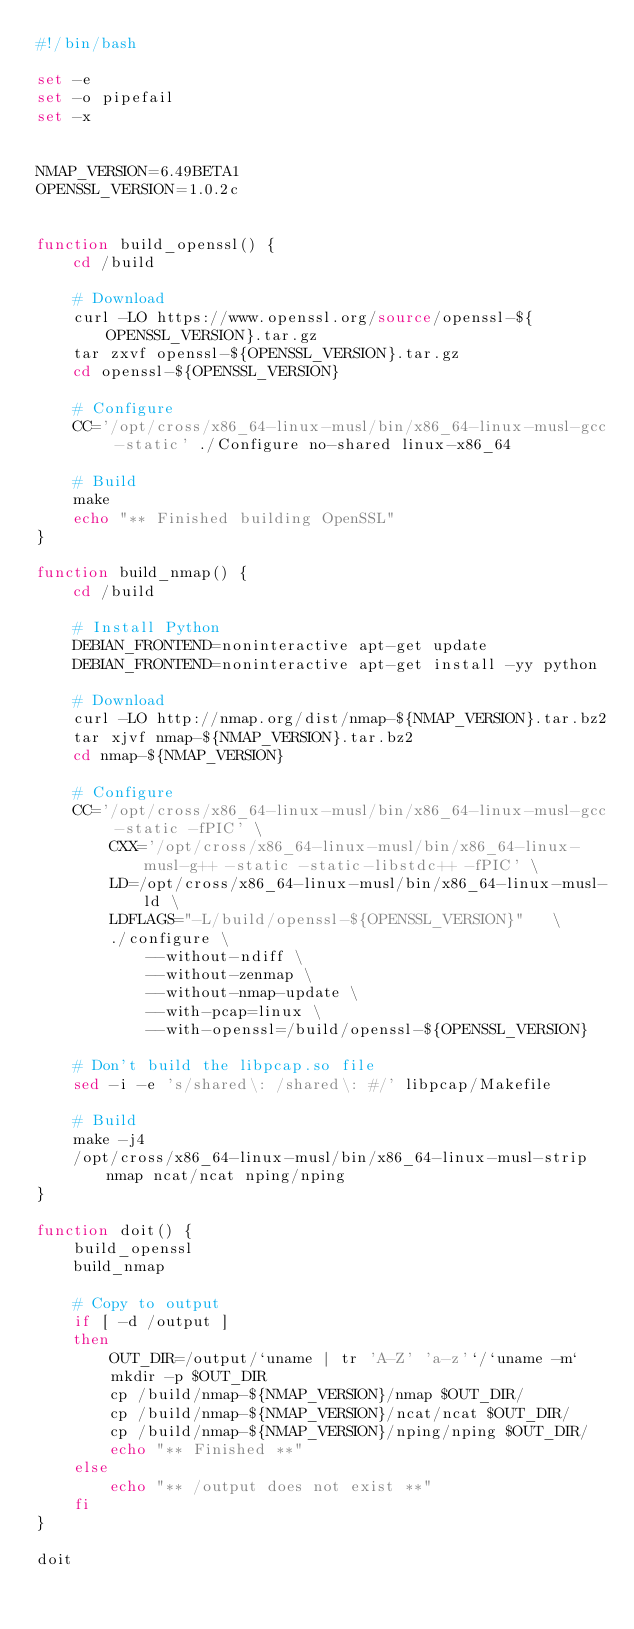<code> <loc_0><loc_0><loc_500><loc_500><_Bash_>#!/bin/bash

set -e
set -o pipefail
set -x


NMAP_VERSION=6.49BETA1
OPENSSL_VERSION=1.0.2c


function build_openssl() {
    cd /build

    # Download
    curl -LO https://www.openssl.org/source/openssl-${OPENSSL_VERSION}.tar.gz
    tar zxvf openssl-${OPENSSL_VERSION}.tar.gz
    cd openssl-${OPENSSL_VERSION}

    # Configure
    CC='/opt/cross/x86_64-linux-musl/bin/x86_64-linux-musl-gcc -static' ./Configure no-shared linux-x86_64

    # Build
    make
    echo "** Finished building OpenSSL"
}

function build_nmap() {
    cd /build

    # Install Python
    DEBIAN_FRONTEND=noninteractive apt-get update
    DEBIAN_FRONTEND=noninteractive apt-get install -yy python

    # Download
    curl -LO http://nmap.org/dist/nmap-${NMAP_VERSION}.tar.bz2
    tar xjvf nmap-${NMAP_VERSION}.tar.bz2
    cd nmap-${NMAP_VERSION}

    # Configure
    CC='/opt/cross/x86_64-linux-musl/bin/x86_64-linux-musl-gcc -static -fPIC' \
        CXX='/opt/cross/x86_64-linux-musl/bin/x86_64-linux-musl-g++ -static -static-libstdc++ -fPIC' \
        LD=/opt/cross/x86_64-linux-musl/bin/x86_64-linux-musl-ld \
        LDFLAGS="-L/build/openssl-${OPENSSL_VERSION}"   \
        ./configure \
            --without-ndiff \
            --without-zenmap \
            --without-nmap-update \
            --with-pcap=linux \
            --with-openssl=/build/openssl-${OPENSSL_VERSION}

    # Don't build the libpcap.so file
    sed -i -e 's/shared\: /shared\: #/' libpcap/Makefile

    # Build
    make -j4
    /opt/cross/x86_64-linux-musl/bin/x86_64-linux-musl-strip nmap ncat/ncat nping/nping
}

function doit() {
    build_openssl
    build_nmap

    # Copy to output
    if [ -d /output ]
    then
        OUT_DIR=/output/`uname | tr 'A-Z' 'a-z'`/`uname -m`
        mkdir -p $OUT_DIR
        cp /build/nmap-${NMAP_VERSION}/nmap $OUT_DIR/
        cp /build/nmap-${NMAP_VERSION}/ncat/ncat $OUT_DIR/
        cp /build/nmap-${NMAP_VERSION}/nping/nping $OUT_DIR/
        echo "** Finished **"
    else
        echo "** /output does not exist **"
    fi
}

doit
</code> 